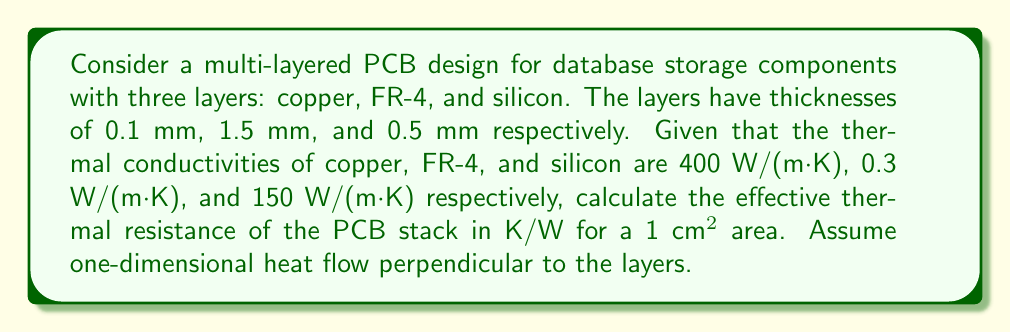Can you solve this math problem? To solve this problem, we'll follow these steps:

1) The thermal resistance for each layer is given by:

   $$R = \frac{L}{kA}$$

   where $L$ is the thickness, $k$ is the thermal conductivity, and $A$ is the area.

2) Calculate the area in m²:
   $A = 1 \text{ cm}^2 = 0.0001 \text{ m}^2$

3) Calculate the thermal resistance for each layer:

   Copper: 
   $$R_1 = \frac{0.0001 \text{ m}}{400 \text{ W/(m·K)} \cdot 0.0001 \text{ m}^2} = 2.5 \text{ K/W}$$

   FR-4:
   $$R_2 = \frac{0.0015 \text{ m}}{0.3 \text{ W/(m·K)} \cdot 0.0001 \text{ m}^2} = 50 \text{ K/W}$$

   Silicon:
   $$R_3 = \frac{0.0005 \text{ m}}{150 \text{ W/(m·K)} \cdot 0.0001 \text{ m}^2} = 0.0333 \text{ K/W}$$

4) The total thermal resistance is the sum of individual resistances:

   $$R_{\text{total}} = R_1 + R_2 + R_3 = 2.5 + 50 + 0.0333 = 52.5333 \text{ K/W}$$

5) Round to three significant figures:

   $$R_{\text{total}} \approx 52.5 \text{ K/W}$$
Answer: 52.5 K/W 